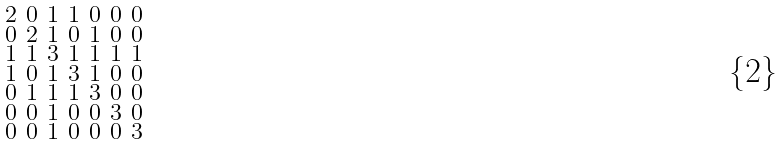<formula> <loc_0><loc_0><loc_500><loc_500>\begin{smallmatrix} 2 & 0 & 1 & 1 & 0 & 0 & 0 \\ 0 & 2 & 1 & 0 & 1 & 0 & 0 \\ 1 & 1 & 3 & 1 & 1 & 1 & 1 \\ 1 & 0 & 1 & 3 & 1 & 0 & 0 \\ 0 & 1 & 1 & 1 & 3 & 0 & 0 \\ 0 & 0 & 1 & 0 & 0 & 3 & 0 \\ 0 & 0 & 1 & 0 & 0 & 0 & 3 \end{smallmatrix}</formula> 